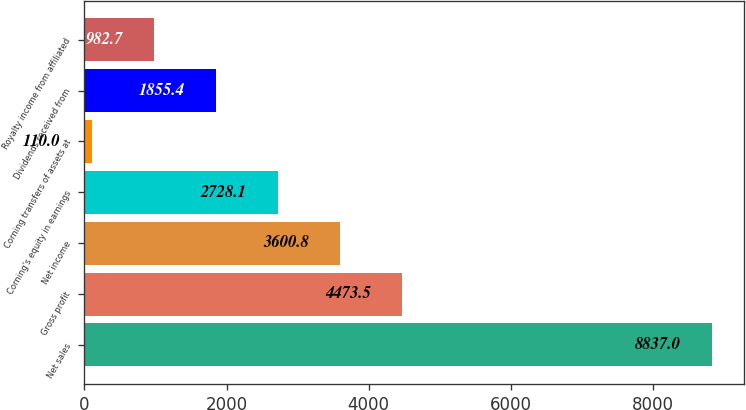Convert chart to OTSL. <chart><loc_0><loc_0><loc_500><loc_500><bar_chart><fcel>Net sales<fcel>Gross profit<fcel>Net income<fcel>Corning's equity in earnings<fcel>Corning transfers of assets at<fcel>Dividends received from<fcel>Royalty income from affiliated<nl><fcel>8837<fcel>4473.5<fcel>3600.8<fcel>2728.1<fcel>110<fcel>1855.4<fcel>982.7<nl></chart> 